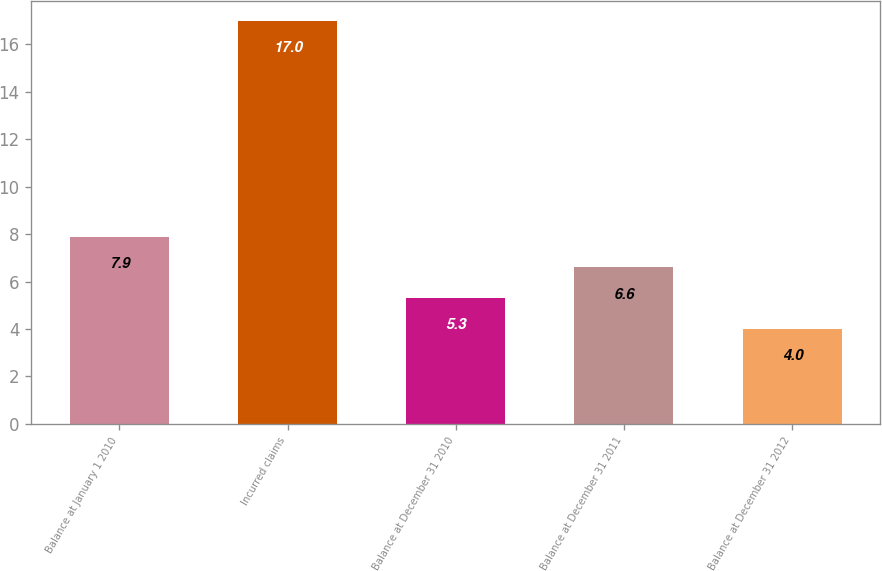<chart> <loc_0><loc_0><loc_500><loc_500><bar_chart><fcel>Balance at January 1 2010<fcel>Incurred claims<fcel>Balance at December 31 2010<fcel>Balance at December 31 2011<fcel>Balance at December 31 2012<nl><fcel>7.9<fcel>17<fcel>5.3<fcel>6.6<fcel>4<nl></chart> 